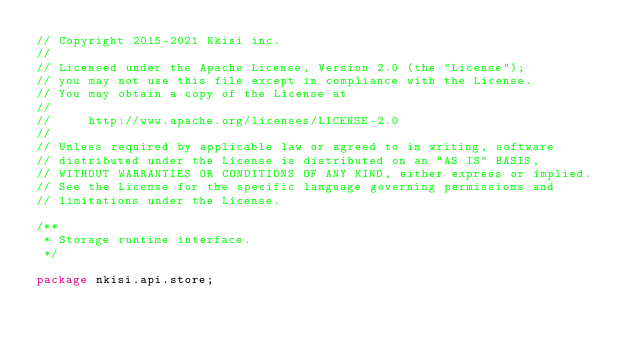Convert code to text. <code><loc_0><loc_0><loc_500><loc_500><_Java_>// Copyright 2015-2021 Nkisi inc.
//
// Licensed under the Apache License, Version 2.0 (the "License");
// you may not use this file except in compliance with the License.
// You may obtain a copy of the License at
//
//     http://www.apache.org/licenses/LICENSE-2.0
//
// Unless required by applicable law or agreed to in writing, software
// distributed under the License is distributed on an "AS IS" BASIS,
// WITHOUT WARRANTIES OR CONDITIONS OF ANY KIND, either express or implied.
// See the License for the specific language governing permissions and
// limitations under the License.

/**
 * Storage runtime interface.
 */

package nkisi.api.store;
</code> 